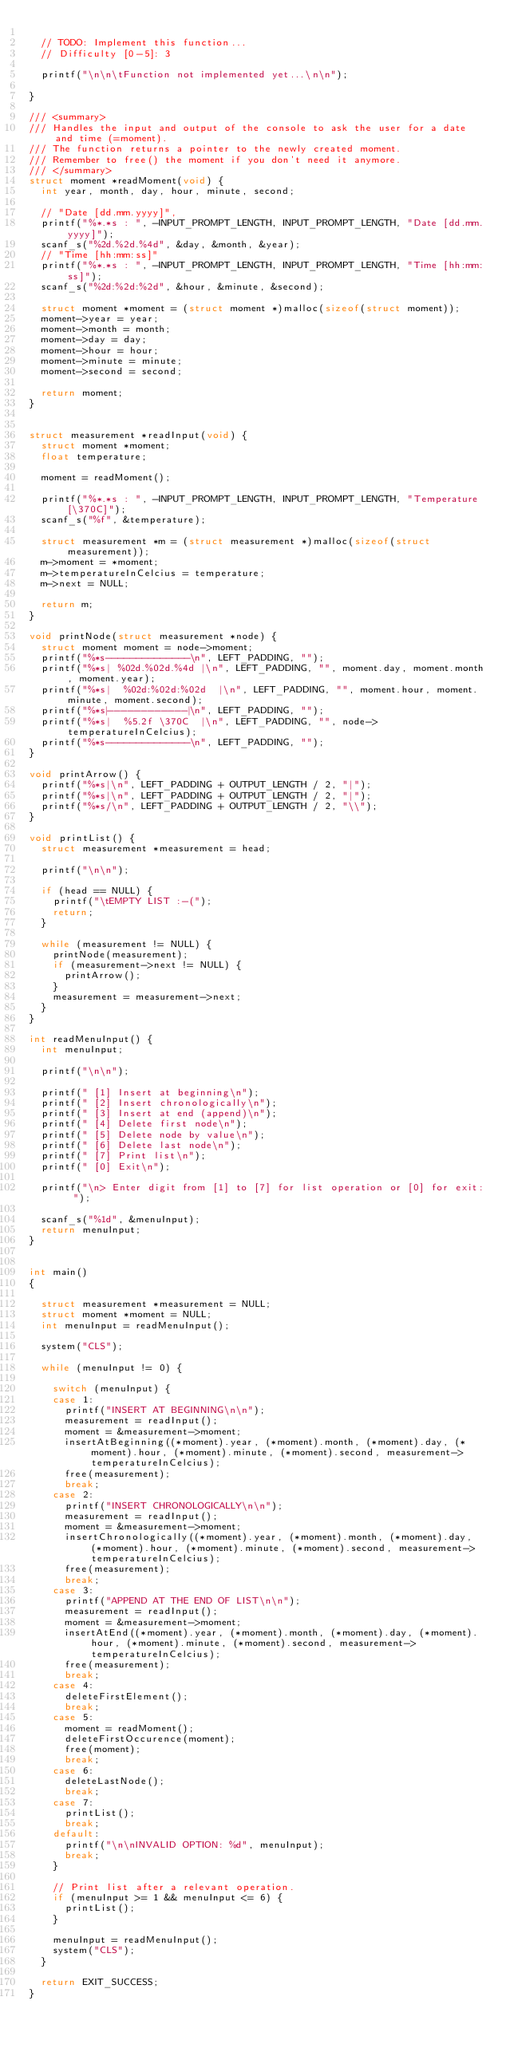<code> <loc_0><loc_0><loc_500><loc_500><_C++_>
	// TODO: Implement this function...
	// Difficulty [0-5]: 3

	printf("\n\n\tFunction not implemented yet...\n\n");

}

/// <summary>
/// Handles the input and output of the console to ask the user for a date and time (=moment).
/// The function returns a pointer to the newly created moment.
/// Remember to free() the moment if you don't need it anymore.
/// </summary>
struct moment *readMoment(void) {
	int year, month, day, hour, minute, second;

	// "Date [dd.mm.yyyy]",
	printf("%*.*s : ", -INPUT_PROMPT_LENGTH, INPUT_PROMPT_LENGTH, "Date [dd.mm.yyyy]");
	scanf_s("%2d.%2d.%4d", &day, &month, &year);
	// "Time [hh:mm:ss]"
	printf("%*.*s : ", -INPUT_PROMPT_LENGTH, INPUT_PROMPT_LENGTH, "Time [hh:mm:ss]");
	scanf_s("%2d:%2d:%2d", &hour, &minute, &second);

	struct moment *moment = (struct moment *)malloc(sizeof(struct moment));
	moment->year = year;
	moment->month = month;
	moment->day = day;
	moment->hour = hour;
	moment->minute = minute;
	moment->second = second;

	return moment;
}


struct measurement *readInput(void) {
	struct moment *moment;
	float temperature;

	moment = readMoment();

	printf("%*.*s : ", -INPUT_PROMPT_LENGTH, INPUT_PROMPT_LENGTH, "Temperature [\370C]");
	scanf_s("%f", &temperature);

	struct measurement *m = (struct measurement *)malloc(sizeof(struct measurement));
	m->moment = *moment;
	m->temperatureInCelcius = temperature;
	m->next = NULL;

	return m;
}

void printNode(struct measurement *node) {
	struct moment moment = node->moment;
	printf("%*s--------------\n", LEFT_PADDING, "");
	printf("%*s| %02d.%02d.%4d |\n", LEFT_PADDING, "", moment.day, moment.month, moment.year);
	printf("%*s|  %02d:%02d:%02d  |\n", LEFT_PADDING, "", moment.hour, moment.minute, moment.second);
	printf("%*s|------------|\n", LEFT_PADDING, "");
	printf("%*s|  %5.2f \370C  |\n", LEFT_PADDING, "", node->temperatureInCelcius);
	printf("%*s--------------\n", LEFT_PADDING, "");
}

void printArrow() {
	printf("%*s|\n", LEFT_PADDING + OUTPUT_LENGTH / 2, "|");
	printf("%*s|\n", LEFT_PADDING + OUTPUT_LENGTH / 2, "|");
	printf("%*s/\n", LEFT_PADDING + OUTPUT_LENGTH / 2, "\\");
}

void printList() {
	struct measurement *measurement = head;

	printf("\n\n");

	if (head == NULL) {
		printf("\tEMPTY LIST :-(");
		return;
	}

	while (measurement != NULL) {
		printNode(measurement);
		if (measurement->next != NULL) {
			printArrow();
		}
		measurement = measurement->next;
	}
}

int readMenuInput() {
	int menuInput;

	printf("\n\n");

	printf(" [1] Insert at beginning\n");
	printf(" [2] Insert chronologically\n");
	printf(" [3] Insert at end (append)\n");
	printf(" [4] Delete first node\n");
	printf(" [5] Delete node by value\n");
	printf(" [6] Delete last node\n");
	printf(" [7] Print list\n");
	printf(" [0] Exit\n");

	printf("\n> Enter digit from [1] to [7] for list operation or [0] for exit: ");

	scanf_s("%1d", &menuInput);
	return menuInput;
}


int main()
{

	struct measurement *measurement = NULL;
	struct moment *moment = NULL;
	int menuInput = readMenuInput();

	system("CLS");

	while (menuInput != 0) {

		switch (menuInput) {
		case 1:
			printf("INSERT AT BEGINNING\n\n");
			measurement = readInput();
			moment = &measurement->moment;
			insertAtBeginning((*moment).year, (*moment).month, (*moment).day, (*moment).hour, (*moment).minute, (*moment).second, measurement->temperatureInCelcius);
			free(measurement);
			break;
		case 2:
			printf("INSERT CHRONOLOGICALLY\n\n");
			measurement = readInput();
			moment = &measurement->moment;
			insertChronologically((*moment).year, (*moment).month, (*moment).day, (*moment).hour, (*moment).minute, (*moment).second, measurement->temperatureInCelcius);
			free(measurement);
			break;
		case 3:
			printf("APPEND AT THE END OF LIST\n\n");
			measurement = readInput();
			moment = &measurement->moment;
			insertAtEnd((*moment).year, (*moment).month, (*moment).day, (*moment).hour, (*moment).minute, (*moment).second, measurement->temperatureInCelcius);
			free(measurement);
			break;
		case 4:
			deleteFirstElement();
			break;
		case 5:
			moment = readMoment();
			deleteFirstOccurence(moment);
			free(moment);
			break;
		case 6:
			deleteLastNode();
			break;
		case 7:
			printList();
			break;
		default:
			printf("\n\nINVALID OPTION: %d", menuInput);
			break;
		}

		// Print list after a relevant operation.
		if (menuInput >= 1 && menuInput <= 6) {
			printList();
		}

		menuInput = readMenuInput();
		system("CLS");
	}

	return EXIT_SUCCESS;
}
</code> 